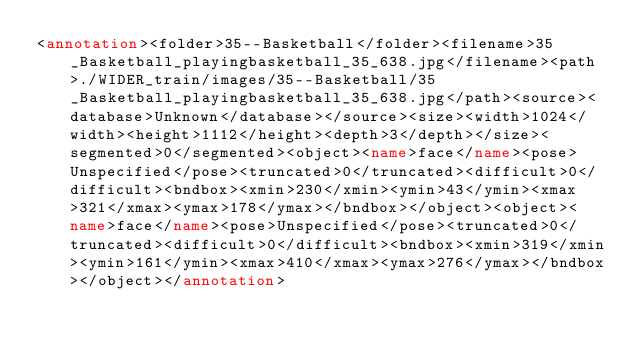Convert code to text. <code><loc_0><loc_0><loc_500><loc_500><_XML_><annotation><folder>35--Basketball</folder><filename>35_Basketball_playingbasketball_35_638.jpg</filename><path>./WIDER_train/images/35--Basketball/35_Basketball_playingbasketball_35_638.jpg</path><source><database>Unknown</database></source><size><width>1024</width><height>1112</height><depth>3</depth></size><segmented>0</segmented><object><name>face</name><pose>Unspecified</pose><truncated>0</truncated><difficult>0</difficult><bndbox><xmin>230</xmin><ymin>43</ymin><xmax>321</xmax><ymax>178</ymax></bndbox></object><object><name>face</name><pose>Unspecified</pose><truncated>0</truncated><difficult>0</difficult><bndbox><xmin>319</xmin><ymin>161</ymin><xmax>410</xmax><ymax>276</ymax></bndbox></object></annotation></code> 